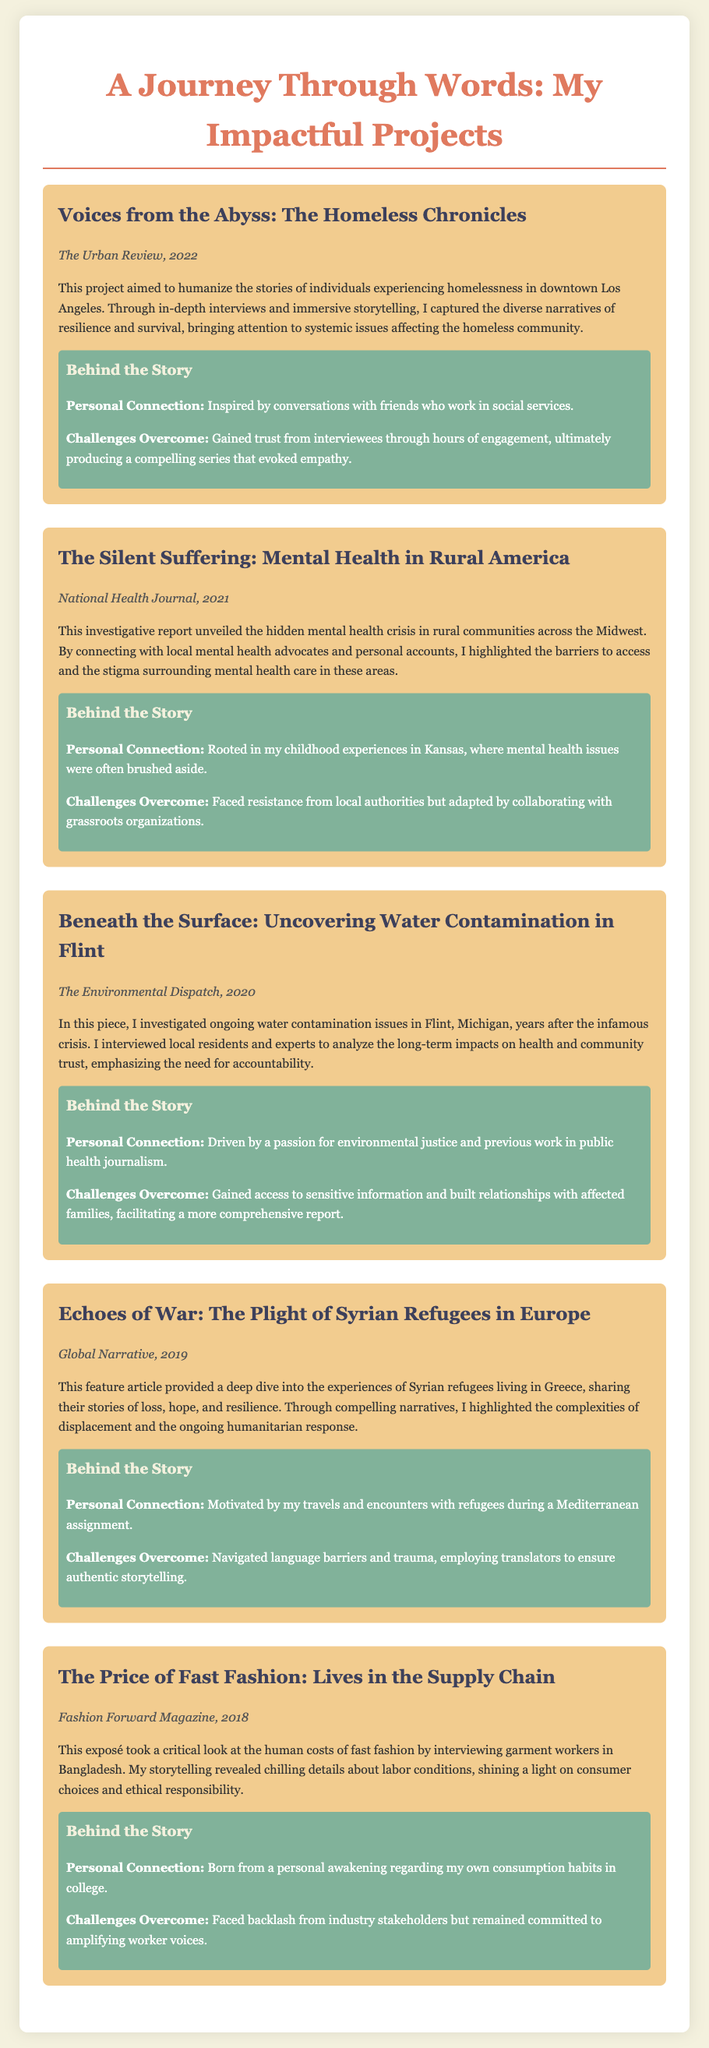What is the title of the first project? The title of the first project is mentioned at the beginning of the project section.
Answer: Voices from the Abyss: The Homeless Chronicles In which publication was "The Silent Suffering" featured? The publication name is given in the project details for "The Silent Suffering".
Answer: National Health Journal What year was the project on Flint's water contamination published? The year is specified in the project details, indicating when the investigation was released.
Answer: 2020 What was the key focus of "Echoes of War"? The focus is included in the project description summarizing the article's content.
Answer: Experiences of Syrian refugees What challenge did the journalist face while reporting on fast fashion? The challenge encountered is part of the project description, outlining difficulties faced in the reporting process.
Answer: Backlash from industry stakeholders How many projects are listed in the document? The total number of projects can be counted within the document sections.
Answer: Five 